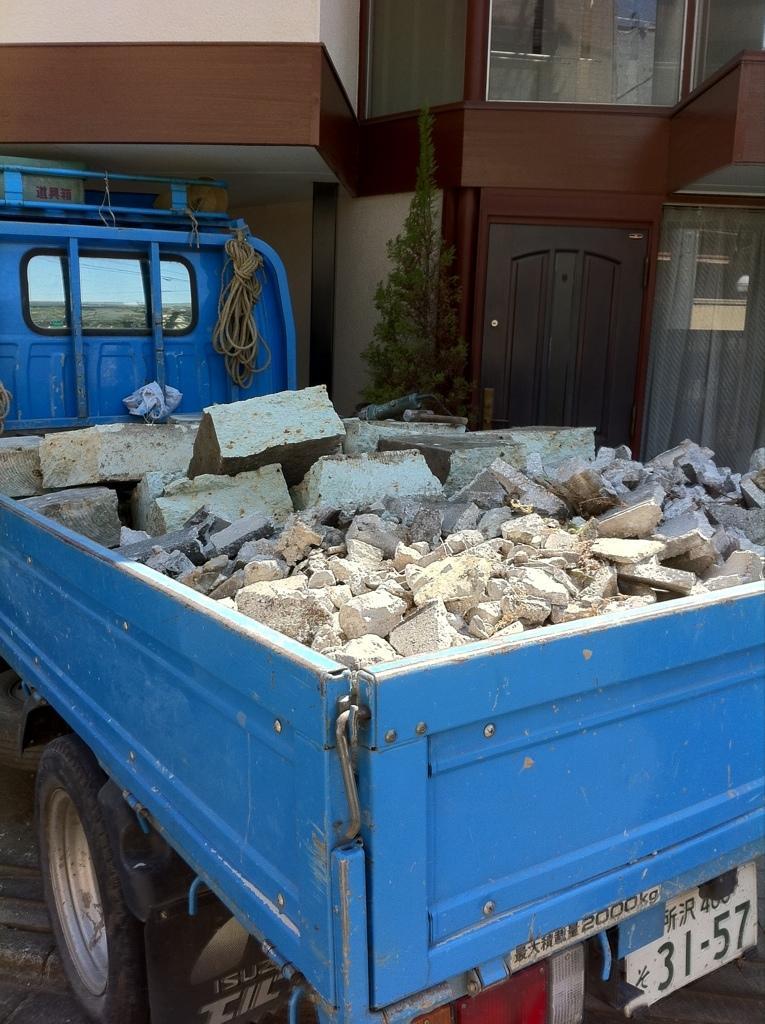How would you summarize this image in a sentence or two? In this image we can see a vehicle with the stones and also a rope. In the background we can see the building with the door and glass windows. We can also see the tree and also the path. 